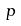Convert formula to latex. <formula><loc_0><loc_0><loc_500><loc_500>p</formula> 